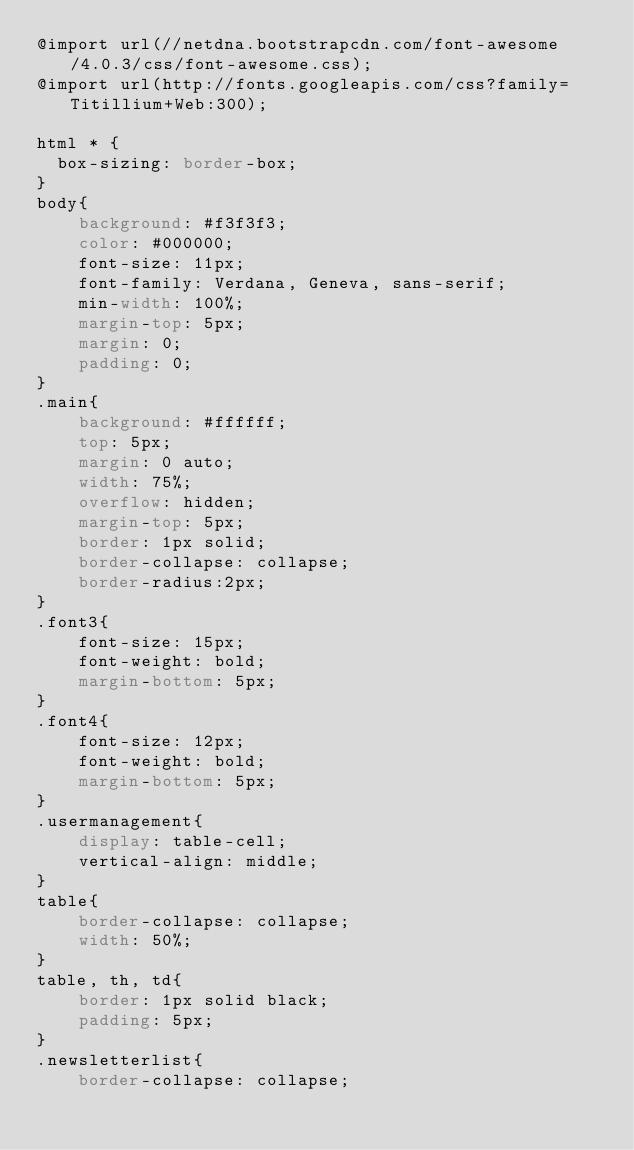<code> <loc_0><loc_0><loc_500><loc_500><_CSS_>@import url(//netdna.bootstrapcdn.com/font-awesome/4.0.3/css/font-awesome.css);
@import url(http://fonts.googleapis.com/css?family=Titillium+Web:300);

html * {
  box-sizing: border-box;
}
body{
    background: #f3f3f3;
    color: #000000;
    font-size: 11px;
    font-family: Verdana, Geneva, sans-serif;
    min-width: 100%;
    margin-top: 5px;
    margin: 0;
    padding: 0;
}
.main{
    background: #ffffff;
    top: 5px;
    margin: 0 auto;
    width: 75%;
    overflow: hidden;
    margin-top: 5px;
    border: 1px solid;
    border-collapse: collapse;
	border-radius:2px;
}
.font3{
    font-size: 15px;
    font-weight: bold;
    margin-bottom: 5px;
}
.font4{
    font-size: 12px;
    font-weight: bold;
    margin-bottom: 5px;
}
.usermanagement{
    display: table-cell;
    vertical-align: middle;
}
table{
    border-collapse: collapse;
    width: 50%;
}
table, th, td{
    border: 1px solid black;
    padding: 5px;
}
.newsletterlist{
    border-collapse: collapse;</code> 